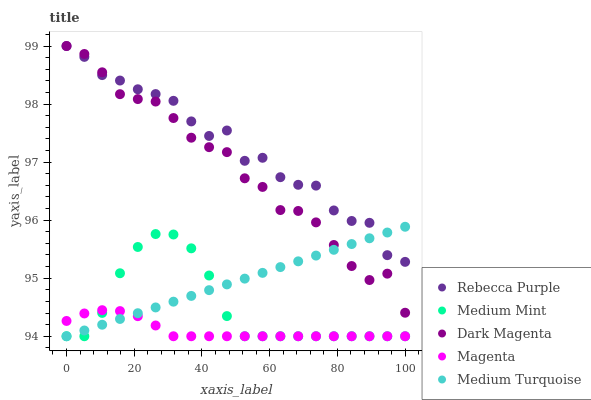Does Magenta have the minimum area under the curve?
Answer yes or no. Yes. Does Rebecca Purple have the maximum area under the curve?
Answer yes or no. Yes. Does Rebecca Purple have the minimum area under the curve?
Answer yes or no. No. Does Magenta have the maximum area under the curve?
Answer yes or no. No. Is Medium Turquoise the smoothest?
Answer yes or no. Yes. Is Rebecca Purple the roughest?
Answer yes or no. Yes. Is Magenta the smoothest?
Answer yes or no. No. Is Magenta the roughest?
Answer yes or no. No. Does Medium Mint have the lowest value?
Answer yes or no. Yes. Does Rebecca Purple have the lowest value?
Answer yes or no. No. Does Dark Magenta have the highest value?
Answer yes or no. Yes. Does Magenta have the highest value?
Answer yes or no. No. Is Magenta less than Dark Magenta?
Answer yes or no. Yes. Is Rebecca Purple greater than Medium Mint?
Answer yes or no. Yes. Does Dark Magenta intersect Medium Turquoise?
Answer yes or no. Yes. Is Dark Magenta less than Medium Turquoise?
Answer yes or no. No. Is Dark Magenta greater than Medium Turquoise?
Answer yes or no. No. Does Magenta intersect Dark Magenta?
Answer yes or no. No. 